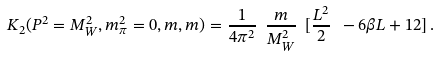Convert formula to latex. <formula><loc_0><loc_0><loc_500><loc_500>K _ { 2 } ( P ^ { 2 } = M _ { W } ^ { 2 } , m _ { \pi } ^ { 2 } = 0 , m , m ) = \frac { 1 } { 4 \pi ^ { 2 } } \ \frac { m } { M _ { W } ^ { 2 } } \ [ \frac { L ^ { 2 } } { 2 } \ - 6 \beta L + 1 2 ] \, .</formula> 